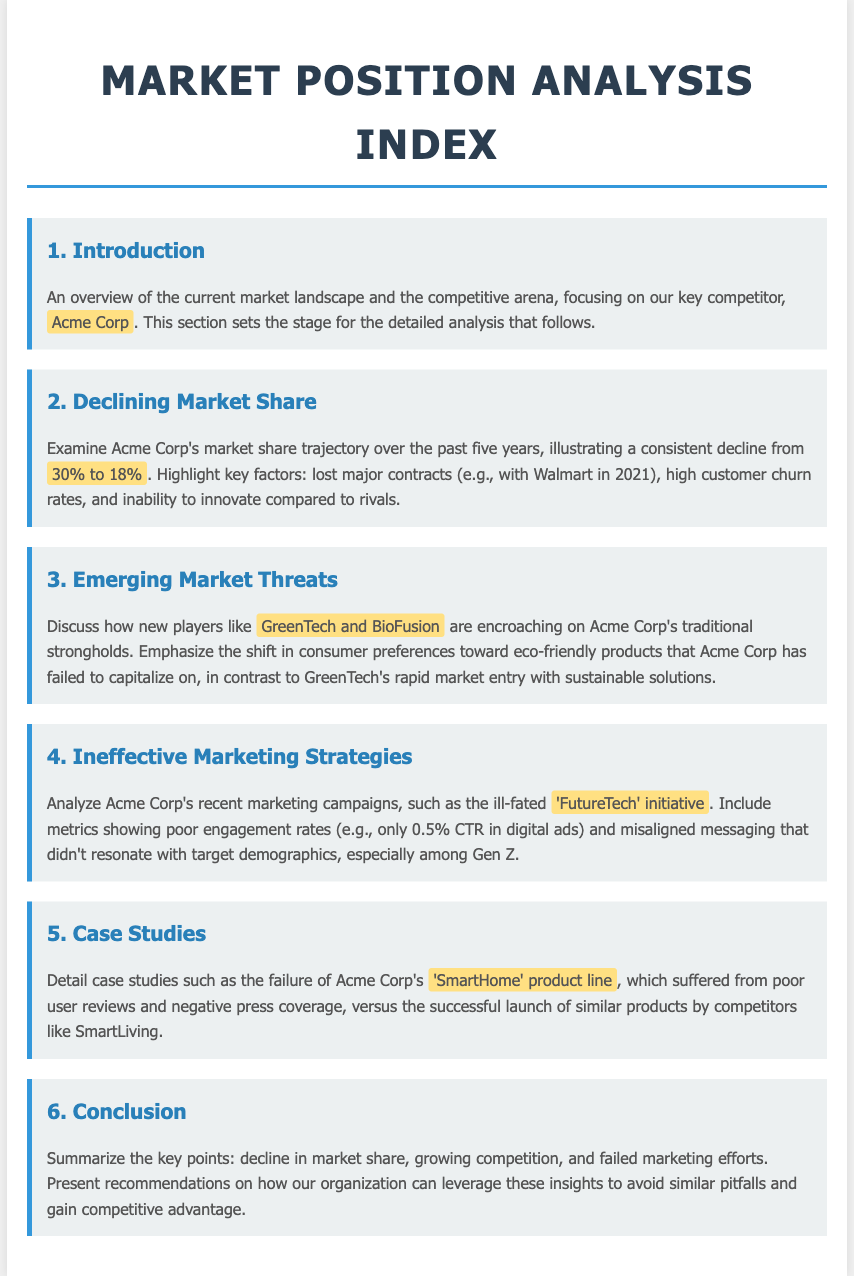What is the name of the key competitor discussed? The document highlights the key competitor as Acme Corp throughout various sections.
Answer: Acme Corp What was Acme Corp's market share in 2021? The document states that Acme Corp's market share was 30% in 2021, before a decline.
Answer: 30% What is Acme Corp's current market share? It is indicated in the document that Acme Corp's current market share has declined to 18%.
Answer: 18% Which new players are threatening Acme Corp's market position? The document mentions GreenTech and BioFusion as emerging competitors damaging Acme Corp's strongholds.
Answer: GreenTech and BioFusion What was the click-through rate of Acme Corp's digital ads? The document specifies that the click-through rate on Acme Corp's digital ads was only 0.5%.
Answer: 0.5% What failed marketing initiative was analyzed? The document highlights Acme Corp's 'FutureTech' initiative as an ineffective marketing effort.
Answer: FutureTech What product line suffered from poor user reviews? The document details the failure of Acme Corp's 'SmartHome' product line due to negative reception.
Answer: SmartHome What shift in consumer preferences is noted in the document? The document emphasizes a shift towards eco-friendly products that Acme Corp has ignored.
Answer: Eco-friendly products What year did Acme Corp lose a major contract? The document states that Acme Corp lost a significant contract with Walmart in 2021.
Answer: 2021 